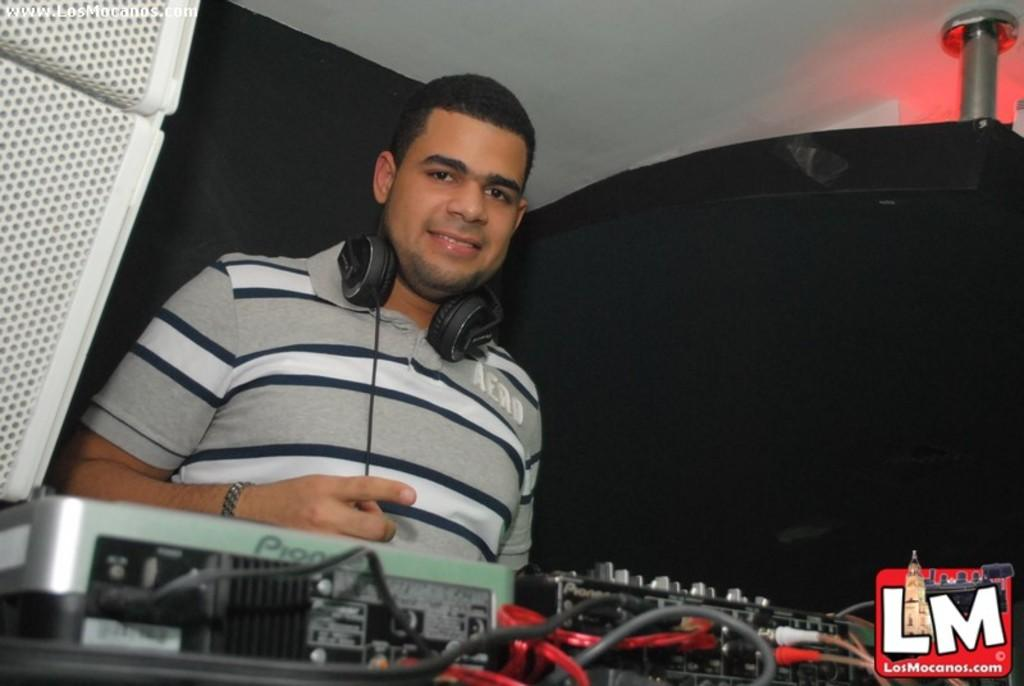What is the main subject of the image? The main subject of the image is a man. What is the man wearing on his head? The man is wearing a headset. What type of clothing is the man wearing on his upper body? The man is wearing a t-shirt. What is the man's facial expression in the image? The man is smiling. What type of steel is the man holding in the image? There is no steel present in the image; the man is not holding anything. 